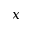<formula> <loc_0><loc_0><loc_500><loc_500>x</formula> 